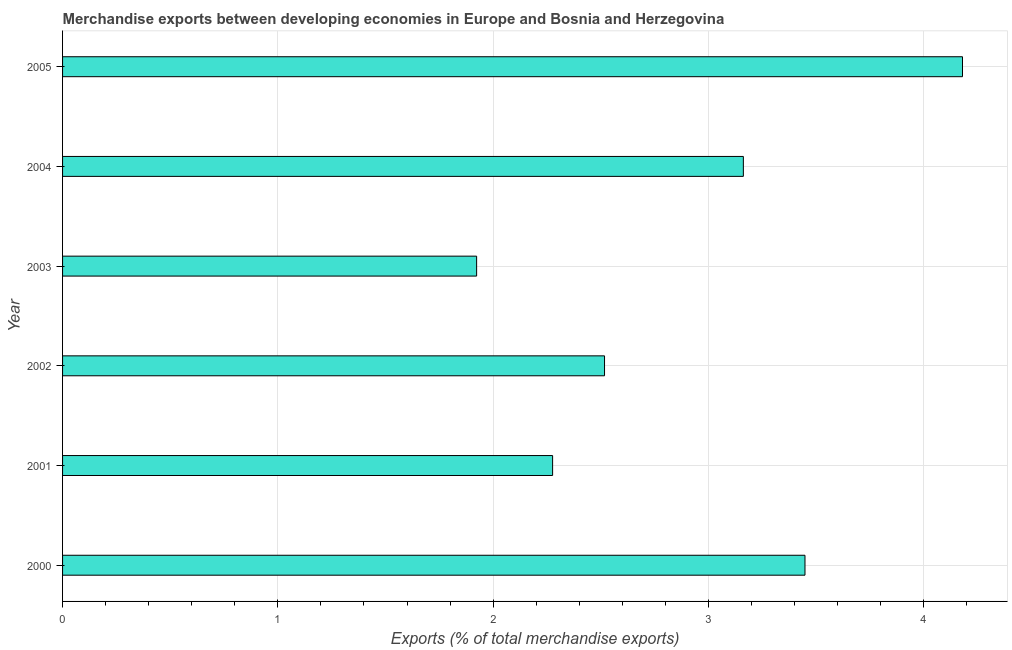Does the graph contain grids?
Give a very brief answer. Yes. What is the title of the graph?
Make the answer very short. Merchandise exports between developing economies in Europe and Bosnia and Herzegovina. What is the label or title of the X-axis?
Offer a terse response. Exports (% of total merchandise exports). What is the merchandise exports in 2004?
Offer a terse response. 3.16. Across all years, what is the maximum merchandise exports?
Provide a short and direct response. 4.18. Across all years, what is the minimum merchandise exports?
Give a very brief answer. 1.92. In which year was the merchandise exports maximum?
Offer a very short reply. 2005. In which year was the merchandise exports minimum?
Your answer should be very brief. 2003. What is the sum of the merchandise exports?
Your response must be concise. 17.51. What is the difference between the merchandise exports in 2002 and 2003?
Keep it short and to the point. 0.59. What is the average merchandise exports per year?
Ensure brevity in your answer.  2.92. What is the median merchandise exports?
Provide a short and direct response. 2.84. In how many years, is the merchandise exports greater than 1.8 %?
Make the answer very short. 6. Do a majority of the years between 2001 and 2005 (inclusive) have merchandise exports greater than 0.2 %?
Your answer should be compact. Yes. What is the ratio of the merchandise exports in 2000 to that in 2003?
Offer a terse response. 1.79. Is the merchandise exports in 2000 less than that in 2002?
Offer a terse response. No. What is the difference between the highest and the second highest merchandise exports?
Your answer should be very brief. 0.73. What is the difference between the highest and the lowest merchandise exports?
Your response must be concise. 2.26. In how many years, is the merchandise exports greater than the average merchandise exports taken over all years?
Keep it short and to the point. 3. How many bars are there?
Offer a very short reply. 6. How many years are there in the graph?
Provide a succinct answer. 6. What is the difference between two consecutive major ticks on the X-axis?
Provide a short and direct response. 1. What is the Exports (% of total merchandise exports) in 2000?
Provide a succinct answer. 3.45. What is the Exports (% of total merchandise exports) in 2001?
Provide a succinct answer. 2.28. What is the Exports (% of total merchandise exports) in 2002?
Make the answer very short. 2.52. What is the Exports (% of total merchandise exports) in 2003?
Offer a terse response. 1.92. What is the Exports (% of total merchandise exports) of 2004?
Your answer should be very brief. 3.16. What is the Exports (% of total merchandise exports) in 2005?
Give a very brief answer. 4.18. What is the difference between the Exports (% of total merchandise exports) in 2000 and 2001?
Offer a terse response. 1.17. What is the difference between the Exports (% of total merchandise exports) in 2000 and 2002?
Offer a very short reply. 0.93. What is the difference between the Exports (% of total merchandise exports) in 2000 and 2003?
Give a very brief answer. 1.53. What is the difference between the Exports (% of total merchandise exports) in 2000 and 2004?
Offer a very short reply. 0.29. What is the difference between the Exports (% of total merchandise exports) in 2000 and 2005?
Provide a short and direct response. -0.73. What is the difference between the Exports (% of total merchandise exports) in 2001 and 2002?
Ensure brevity in your answer.  -0.24. What is the difference between the Exports (% of total merchandise exports) in 2001 and 2003?
Give a very brief answer. 0.35. What is the difference between the Exports (% of total merchandise exports) in 2001 and 2004?
Ensure brevity in your answer.  -0.89. What is the difference between the Exports (% of total merchandise exports) in 2001 and 2005?
Offer a terse response. -1.9. What is the difference between the Exports (% of total merchandise exports) in 2002 and 2003?
Your answer should be very brief. 0.59. What is the difference between the Exports (% of total merchandise exports) in 2002 and 2004?
Ensure brevity in your answer.  -0.64. What is the difference between the Exports (% of total merchandise exports) in 2002 and 2005?
Provide a succinct answer. -1.66. What is the difference between the Exports (% of total merchandise exports) in 2003 and 2004?
Offer a terse response. -1.24. What is the difference between the Exports (% of total merchandise exports) in 2003 and 2005?
Your answer should be very brief. -2.26. What is the difference between the Exports (% of total merchandise exports) in 2004 and 2005?
Give a very brief answer. -1.02. What is the ratio of the Exports (% of total merchandise exports) in 2000 to that in 2001?
Your answer should be very brief. 1.51. What is the ratio of the Exports (% of total merchandise exports) in 2000 to that in 2002?
Offer a very short reply. 1.37. What is the ratio of the Exports (% of total merchandise exports) in 2000 to that in 2003?
Offer a very short reply. 1.79. What is the ratio of the Exports (% of total merchandise exports) in 2000 to that in 2004?
Ensure brevity in your answer.  1.09. What is the ratio of the Exports (% of total merchandise exports) in 2000 to that in 2005?
Provide a succinct answer. 0.82. What is the ratio of the Exports (% of total merchandise exports) in 2001 to that in 2002?
Make the answer very short. 0.9. What is the ratio of the Exports (% of total merchandise exports) in 2001 to that in 2003?
Give a very brief answer. 1.18. What is the ratio of the Exports (% of total merchandise exports) in 2001 to that in 2004?
Ensure brevity in your answer.  0.72. What is the ratio of the Exports (% of total merchandise exports) in 2001 to that in 2005?
Your answer should be compact. 0.55. What is the ratio of the Exports (% of total merchandise exports) in 2002 to that in 2003?
Provide a succinct answer. 1.31. What is the ratio of the Exports (% of total merchandise exports) in 2002 to that in 2004?
Offer a terse response. 0.8. What is the ratio of the Exports (% of total merchandise exports) in 2002 to that in 2005?
Make the answer very short. 0.6. What is the ratio of the Exports (% of total merchandise exports) in 2003 to that in 2004?
Make the answer very short. 0.61. What is the ratio of the Exports (% of total merchandise exports) in 2003 to that in 2005?
Your answer should be very brief. 0.46. What is the ratio of the Exports (% of total merchandise exports) in 2004 to that in 2005?
Your response must be concise. 0.76. 